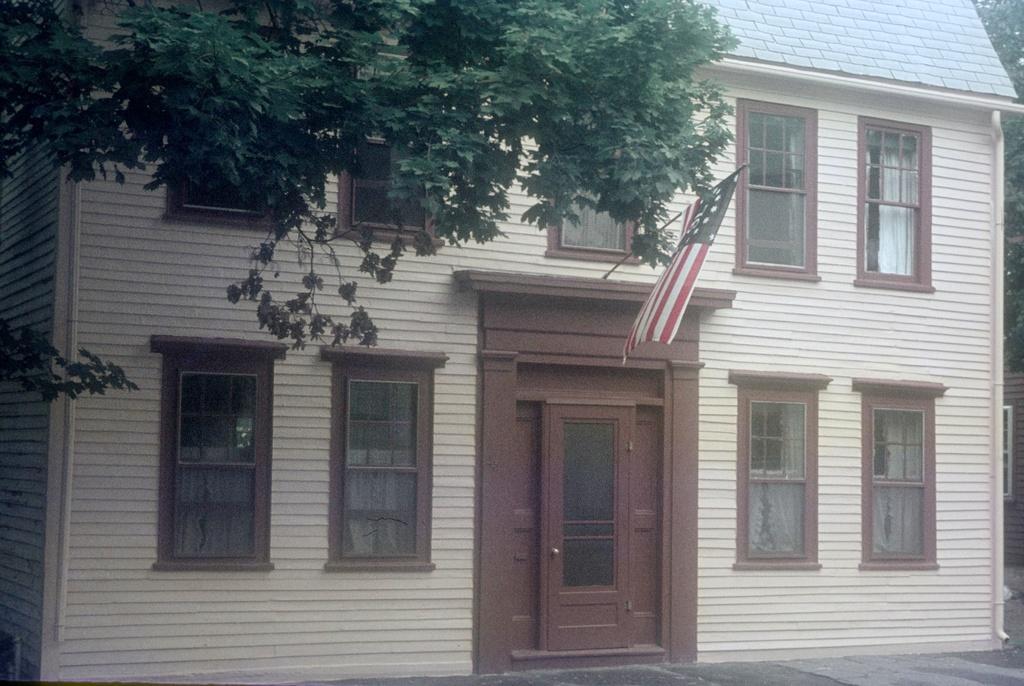Can you describe this image briefly? In the picture we can see a house which has some windows, there is a door, flag and there are some trees. 